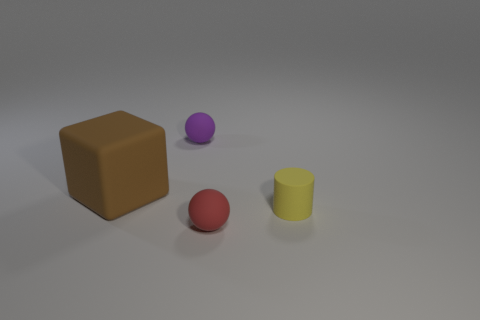There is a small thing that is in front of the purple ball and on the left side of the small yellow rubber cylinder; what shape is it?
Offer a very short reply. Sphere. Is there a small cyan cube made of the same material as the red sphere?
Keep it short and to the point. No. Is the number of small things in front of the big object the same as the number of small things that are left of the tiny yellow matte object?
Your answer should be very brief. Yes. There is a rubber object left of the purple rubber object; what is its size?
Ensure brevity in your answer.  Large. What number of tiny spheres are behind the small ball to the right of the ball that is behind the small red rubber object?
Make the answer very short. 1. Is the sphere behind the large matte object made of the same material as the small sphere in front of the brown cube?
Provide a short and direct response. Yes. How many other tiny rubber objects have the same shape as the brown thing?
Offer a very short reply. 0. Is the number of matte spheres that are in front of the purple rubber object greater than the number of cyan shiny cylinders?
Make the answer very short. Yes. What shape is the tiny matte object that is to the right of the tiny ball on the right side of the ball that is left of the small red object?
Make the answer very short. Cylinder. Do the thing that is in front of the tiny yellow matte thing and the object that is to the left of the purple ball have the same shape?
Ensure brevity in your answer.  No. 